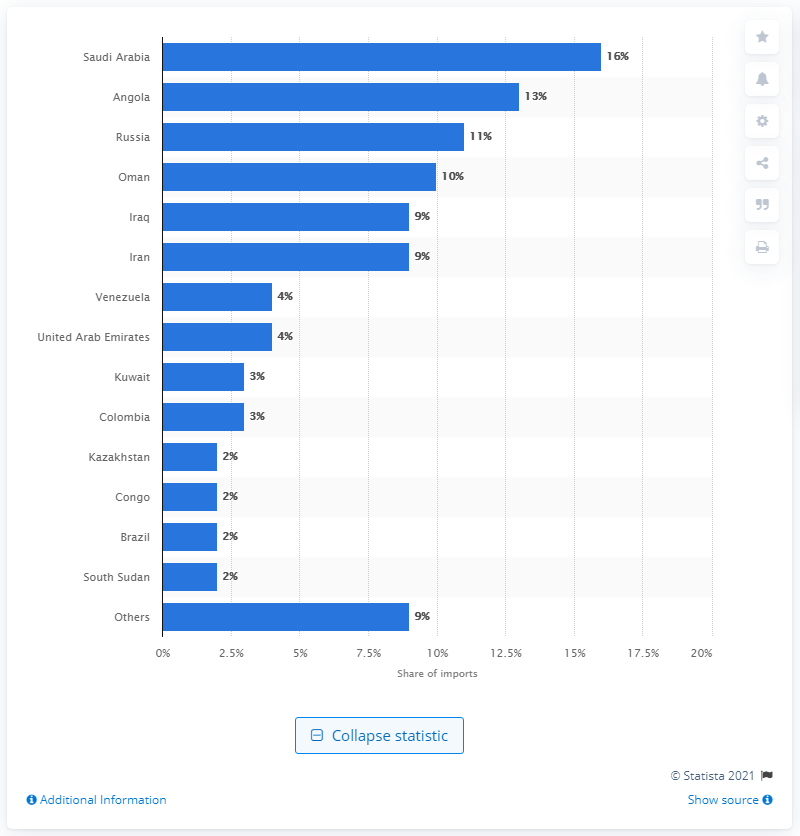Specify some key components in this picture. In China, nine percent of the country's oil imports came from Iran. 